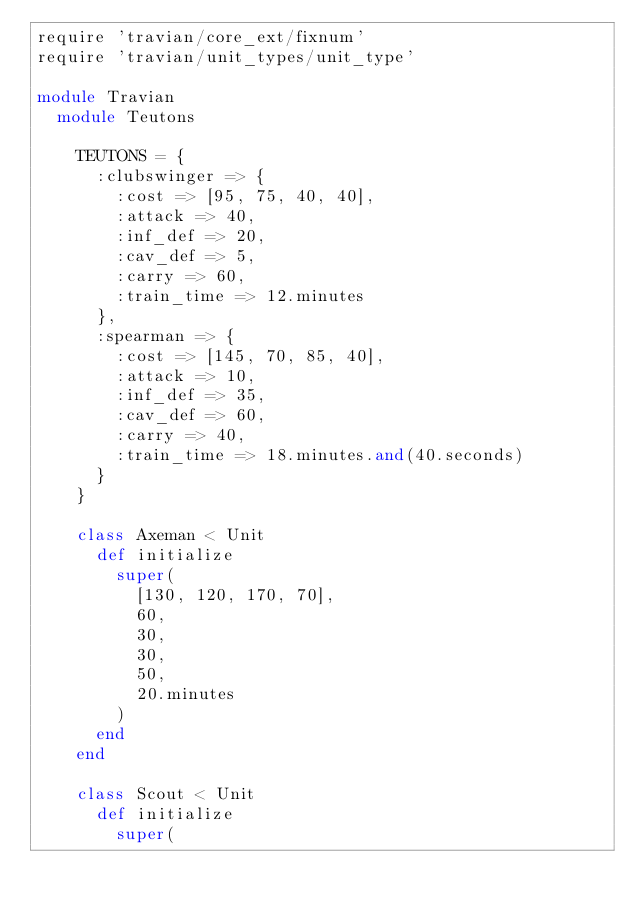<code> <loc_0><loc_0><loc_500><loc_500><_Ruby_>require 'travian/core_ext/fixnum'
require 'travian/unit_types/unit_type'

module Travian
  module Teutons

    TEUTONS = {
      :clubswinger => {
        :cost => [95, 75, 40, 40],
        :attack => 40,
        :inf_def => 20,
        :cav_def => 5,
        :carry => 60,
        :train_time => 12.minutes
      },
      :spearman => {
        :cost => [145, 70, 85, 40],
        :attack => 10,
        :inf_def => 35,
        :cav_def => 60,
        :carry => 40,
        :train_time => 18.minutes.and(40.seconds)
      }
    }

    class Axeman < Unit
      def initialize
        super(
          [130, 120, 170, 70],
          60,
          30,
          30,
          50,
          20.minutes
        )
      end
    end

    class Scout < Unit
      def initialize
        super(</code> 